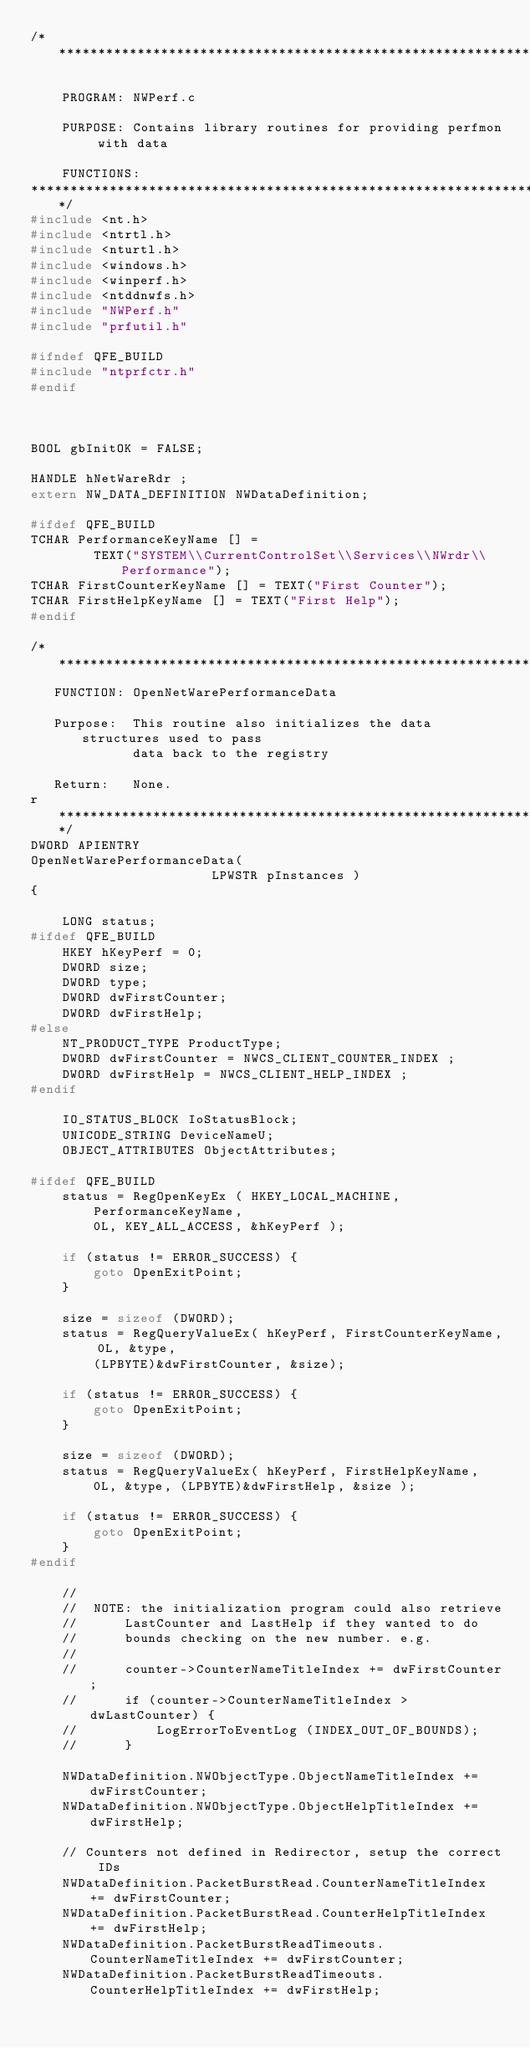Convert code to text. <code><loc_0><loc_0><loc_500><loc_500><_C_>/****************************************************************************

    PROGRAM: NWPerf.c

    PURPOSE: Contains library routines for providing perfmon with data

    FUNCTIONS:
*******************************************************************************/
#include <nt.h>
#include <ntrtl.h>
#include <nturtl.h>
#include <windows.h>
#include <winperf.h>
#include <ntddnwfs.h>
#include "NWPerf.h"
#include "prfutil.h"

#ifndef QFE_BUILD
#include "ntprfctr.h"
#endif



BOOL gbInitOK = FALSE;

HANDLE hNetWareRdr ;
extern NW_DATA_DEFINITION NWDataDefinition;

#ifdef QFE_BUILD
TCHAR PerformanceKeyName [] =
        TEXT("SYSTEM\\CurrentControlSet\\Services\\NWrdr\\Performance");
TCHAR FirstCounterKeyName [] = TEXT("First Counter");
TCHAR FirstHelpKeyName [] = TEXT("First Help");
#endif

/****************************************************************************
   FUNCTION: OpenNetWarePerformanceData

   Purpose:  This routine also initializes the data structures used to pass
             data back to the registry

   Return:   None.
r****************************************************************************/
DWORD APIENTRY
OpenNetWarePerformanceData(
                       LPWSTR pInstances )
{

    LONG status;
#ifdef QFE_BUILD
    HKEY hKeyPerf = 0;
    DWORD size;
    DWORD type;
    DWORD dwFirstCounter;
    DWORD dwFirstHelp;
#else
    NT_PRODUCT_TYPE ProductType;
    DWORD dwFirstCounter = NWCS_CLIENT_COUNTER_INDEX ;
    DWORD dwFirstHelp = NWCS_CLIENT_HELP_INDEX ;
#endif

    IO_STATUS_BLOCK IoStatusBlock;
    UNICODE_STRING DeviceNameU;
    OBJECT_ATTRIBUTES ObjectAttributes;

#ifdef QFE_BUILD
    status = RegOpenKeyEx ( HKEY_LOCAL_MACHINE,
        PerformanceKeyName,
        0L, KEY_ALL_ACCESS, &hKeyPerf );

    if (status != ERROR_SUCCESS) {
        goto OpenExitPoint;
    }

    size = sizeof (DWORD);
    status = RegQueryValueEx( hKeyPerf, FirstCounterKeyName, 0L, &type,
        (LPBYTE)&dwFirstCounter, &size);

    if (status != ERROR_SUCCESS) {
        goto OpenExitPoint;
    }

    size = sizeof (DWORD);
    status = RegQueryValueEx( hKeyPerf, FirstHelpKeyName,
        0L, &type, (LPBYTE)&dwFirstHelp, &size );

    if (status != ERROR_SUCCESS) {
        goto OpenExitPoint;
    }
#endif

    //
    //  NOTE: the initialization program could also retrieve
    //      LastCounter and LastHelp if they wanted to do
    //      bounds checking on the new number. e.g.
    //
    //      counter->CounterNameTitleIndex += dwFirstCounter;
    //      if (counter->CounterNameTitleIndex > dwLastCounter) {
    //          LogErrorToEventLog (INDEX_OUT_OF_BOUNDS);
    //      }

    NWDataDefinition.NWObjectType.ObjectNameTitleIndex += dwFirstCounter;
    NWDataDefinition.NWObjectType.ObjectHelpTitleIndex += dwFirstHelp;

    // Counters not defined in Redirector, setup the correct IDs
    NWDataDefinition.PacketBurstRead.CounterNameTitleIndex += dwFirstCounter;
    NWDataDefinition.PacketBurstRead.CounterHelpTitleIndex += dwFirstHelp;
    NWDataDefinition.PacketBurstReadTimeouts.CounterNameTitleIndex += dwFirstCounter;
    NWDataDefinition.PacketBurstReadTimeouts.CounterHelpTitleIndex += dwFirstHelp;</code> 